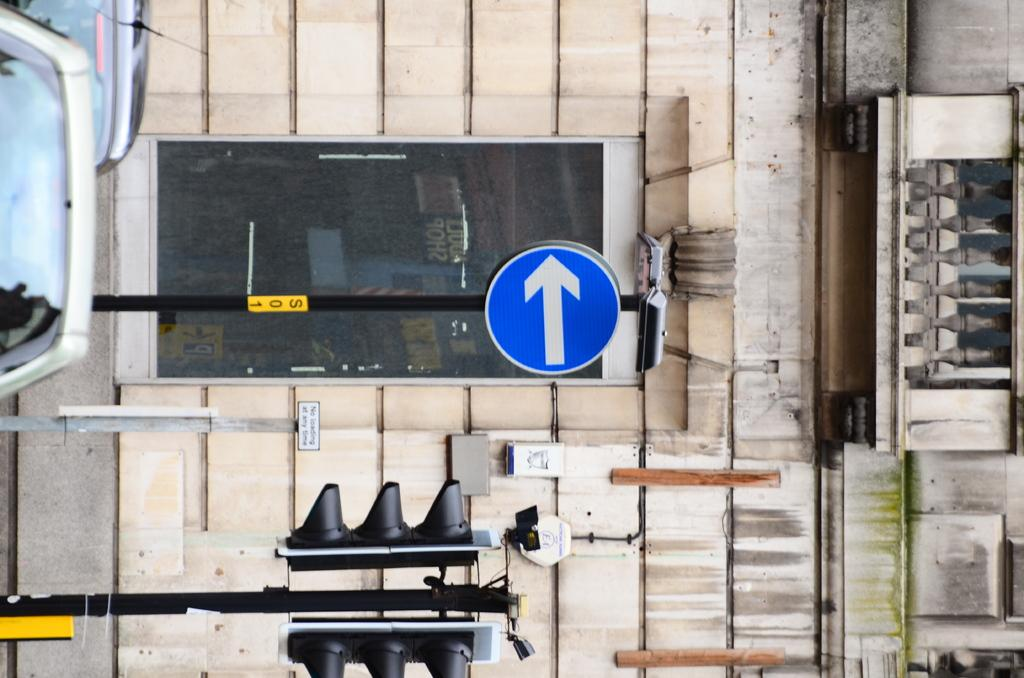What types of objects can be seen in the image? There are vehicles, poles, traffic signals, and a board in the image. What structures are present in the image? There are poles and a wall in the background of the image. What can be seen on the board in the image? The provided facts do not mention any specific details about the board. What is visible in the background of the image? There is a wall and a glass in the background of the image. How many frogs can be seen sitting on the vehicles in the image? There are no frogs present in the image. What color is the eye of the person driving one of the vehicles in the image? There is no person or eye visible in the image. 